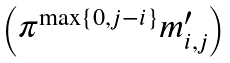Convert formula to latex. <formula><loc_0><loc_0><loc_500><loc_500>\begin{pmatrix} \pi ^ { \max \{ 0 , j - i \} } m _ { i , j } ^ { \prime } \end{pmatrix}</formula> 